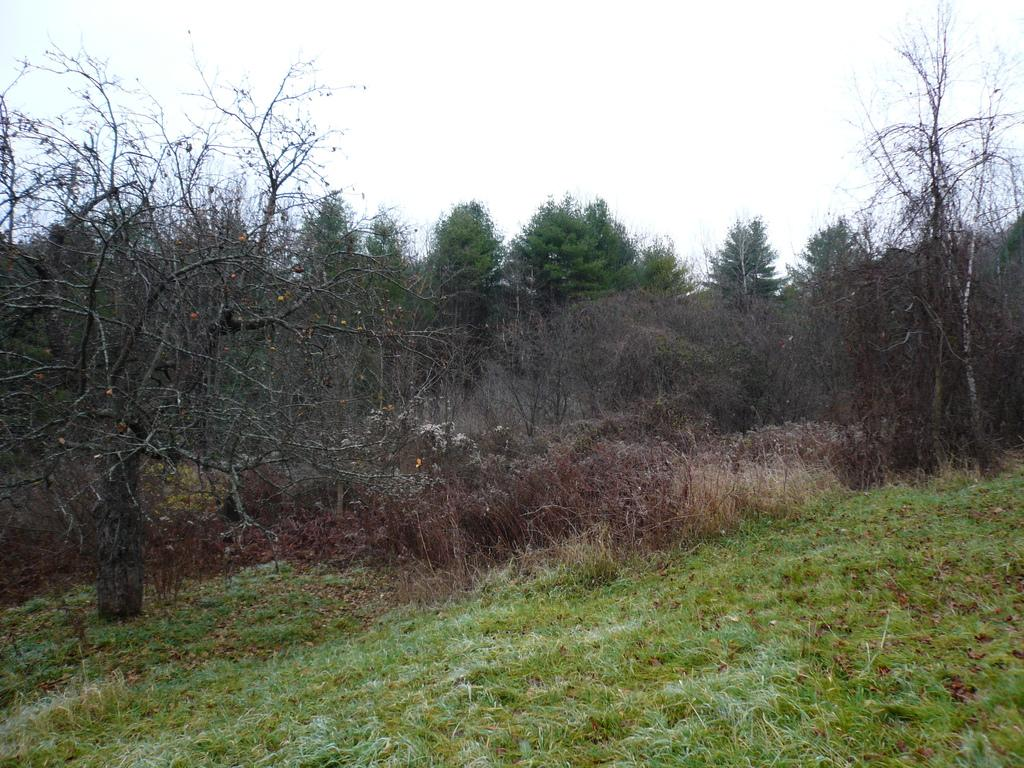What type of vegetation can be seen in the image? There is grass, bushes, and trees in the image. What part of the natural environment is visible in the image? The sky is visible in the image. What type of hat is the camera wearing in the image? There is no camera or hat present in the image. What time of day is depicted in the image? The time of day cannot be determined from the image, as there are no specific clues or indicators of morning or any other time. 